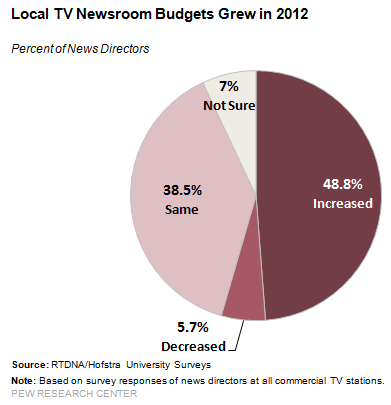List a handful of essential elements in this visual. According to the data, seven percent of respondents were unsure if local TV newsrooms' budgets grew in 2012. The median of three smallest segments is 38.5. 